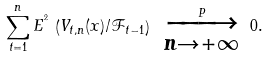<formula> <loc_0><loc_0><loc_500><loc_500>\overset { n } { \underset { t = 1 } { \sum } } \, E ^ { ^ { 2 } } \, \left ( V _ { t , n } ( x ) / \mathcal { F } _ { t - 1 } \right ) \ \overset { P } { \overrightarrow { \underset { n \rightarrow + \infty } } } \ 0 .</formula> 